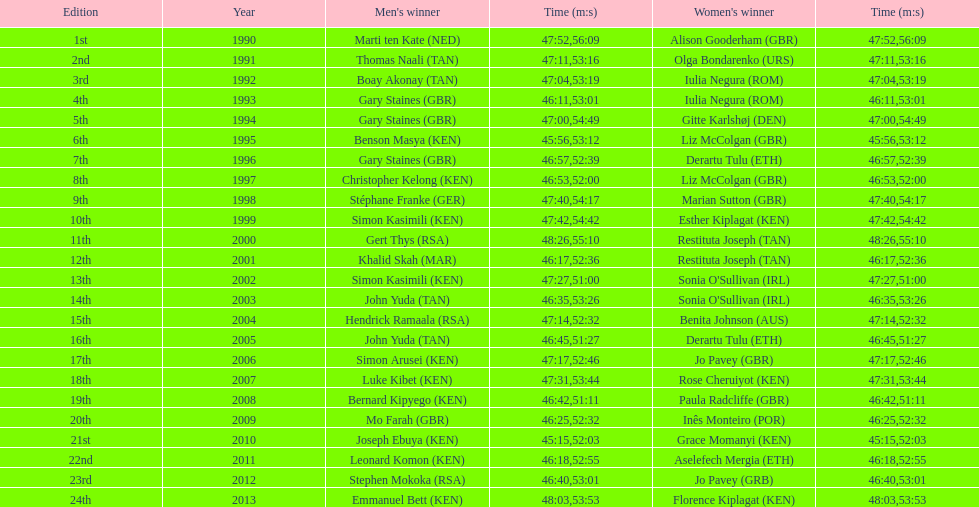How many minutes or seconds did sonia o'sullivan need to complete the race in 2003? 53:26. 